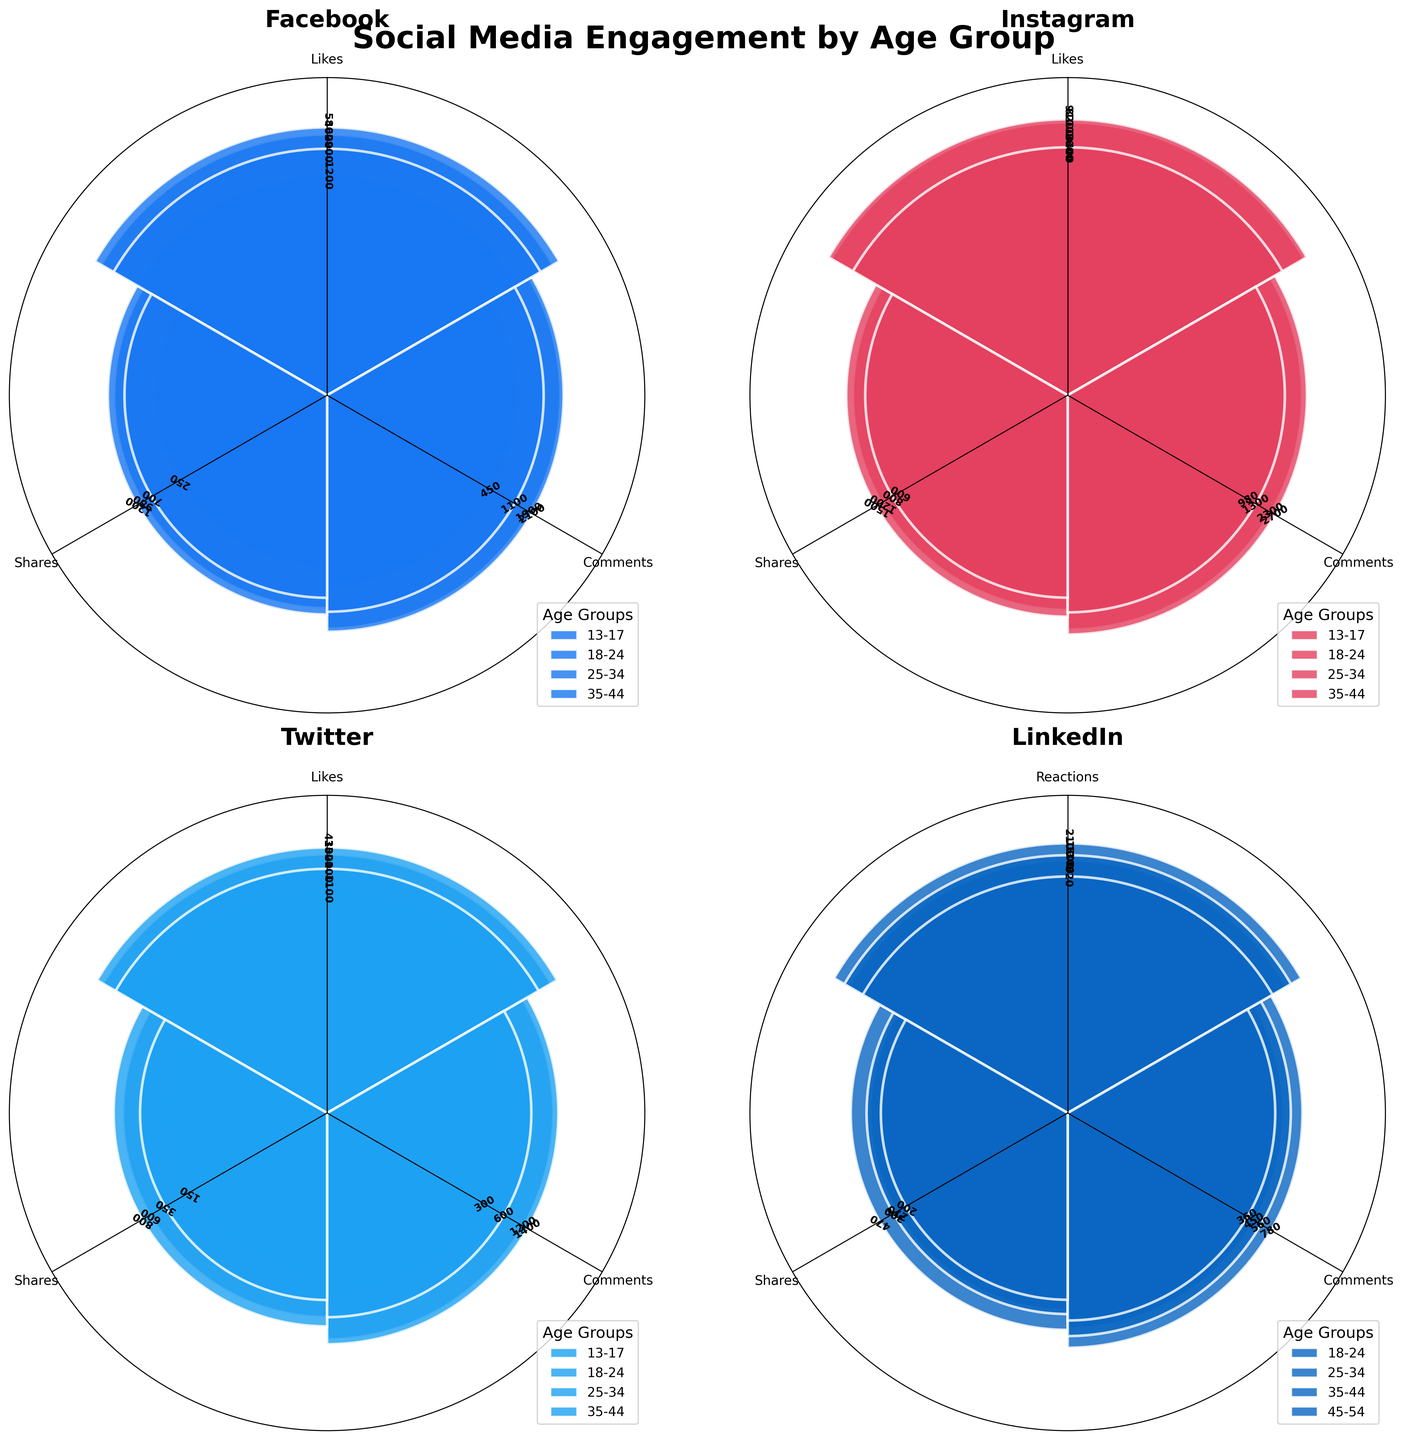What social media platform has the highest engagement count for the age group 25-34? Look at the figure for the platform which shows the highest bar for the age group 25-34. Instagram has the tallest bars for all engagement types.
Answer: Instagram Which age group on Facebook has the least engagement in terms of shares? On the Facebook subplot, compare the bar heights representing shares across all age groups. The age group 13-17 has the shortest bar for shares.
Answer: 13-17 How does the number of comments on Twitter for the age group 18-24 compare to those for the age group 35-44? On the Twitter subplot, compare the heights of the bars that signify the number of comments for age groups 18-24 and 35-44. The 18-24 age group has a noticeably taller bar than the 35-44 age group.
Answer: Higher What is the total engagement count (likes, comments, and shares) for the age group 35-44 on Instagram? Sum the engagement counts for likes, comments, and shares for the 35-44 age group on Instagram. Adding up the numbers: 3600 + 1300 + 800 = 5700.
Answer: 5700 Which age group on LinkedIn shows the highest engagement in terms of shares? For LinkedIn, review which age group has the tallest bar for shares. The age group 25-34 has the highest bar for shares.
Answer: 25-34 What is the range of engagement counts for comments on Instagram for the age groups examined? For Instagram, identify the height of the bars that correspond to comments in all age groups and find the highest and lowest values. The highest value is for age group 25-34 (2700) and the lowest is for age group 13-17 (980), giving a range of 2700 - 980 = 1720.
Answer: 1720 In terms of likes, how does the engagement for age group 18-24 on all platforms compare? Compare the lengths of the bars that represent likes for age group 18-24 across all platforms. Instagram (8200) has taller bars compared to Facebook (4600), Twitter (3300), and LinkedIn shows reactions (1300).
Answer: Instagram Are there any platforms where the 45-54 age group has engagement data? Look through the subplots to determine which platforms include engagement data for the age group 45-54. Only LinkedIn includes engagement data for 45-54.
Answer: LinkedIn Which platform and age group combination has the least number of shares? Identify the platform and age group with the shortest bar for shares across all subplots. Twitter's age group 13-17 has the shortest bar for shares (150).
Answer: Twitter, 13-17 